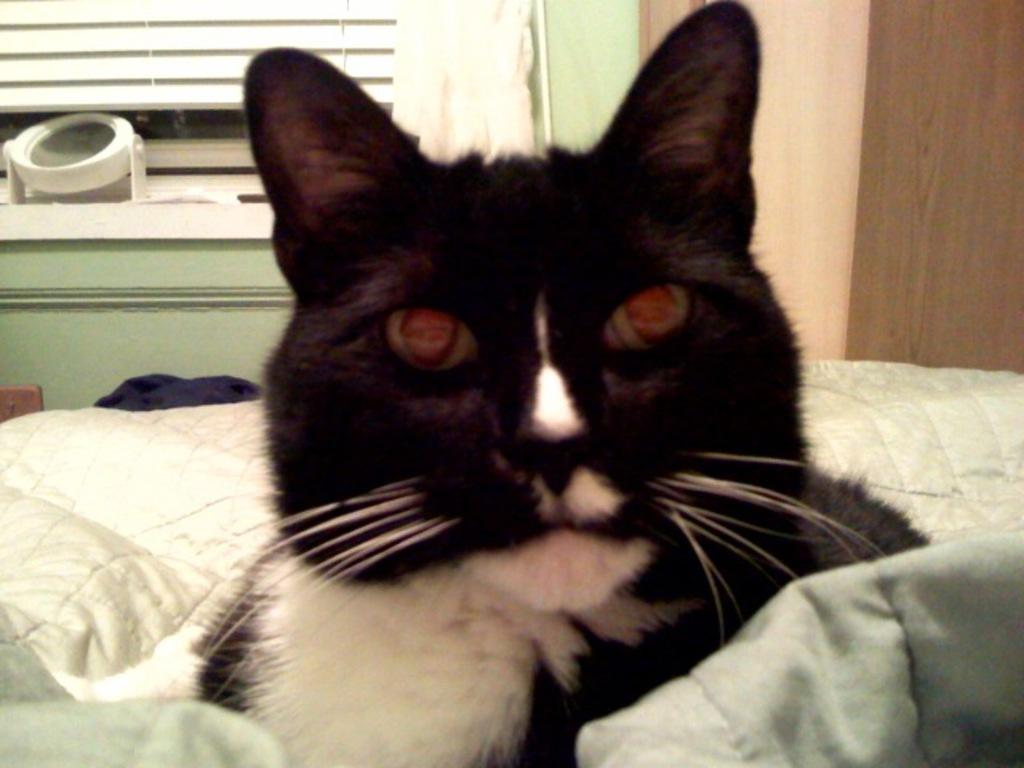What type of space is depicted in the image? The image is of a room. What animal can be seen in the room? There is a cat sitting on the bed. What feature allows natural light into the room? There is a window in the room, and a curtain is associated with it. What architectural element is present in the room? There is a wall in the room. What type of land can be seen through the window in the image? There is no land visible through the window in the image; it only shows a cat sitting on the bed. What part of the human body is associated with the elbow in the image? There is no mention of an elbow or any human body parts in the image. 